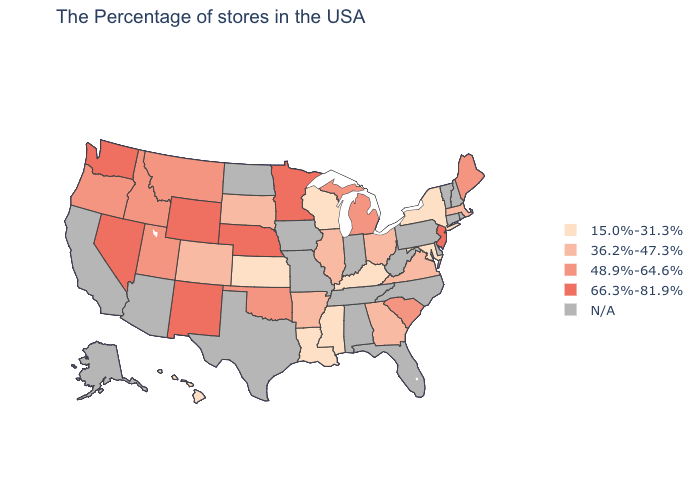What is the lowest value in states that border Kansas?
Quick response, please. 36.2%-47.3%. Does Kansas have the lowest value in the MidWest?
Quick response, please. Yes. What is the highest value in the USA?
Short answer required. 66.3%-81.9%. Name the states that have a value in the range 36.2%-47.3%?
Give a very brief answer. Massachusetts, Virginia, Ohio, Georgia, Illinois, Arkansas, South Dakota, Colorado. Among the states that border North Dakota , which have the highest value?
Write a very short answer. Minnesota. Does the map have missing data?
Give a very brief answer. Yes. What is the value of Colorado?
Short answer required. 36.2%-47.3%. Does the map have missing data?
Write a very short answer. Yes. Does Georgia have the lowest value in the USA?
Short answer required. No. Does Michigan have the lowest value in the USA?
Keep it brief. No. What is the lowest value in the West?
Write a very short answer. 15.0%-31.3%. Which states have the highest value in the USA?
Write a very short answer. New Jersey, Minnesota, Nebraska, Wyoming, New Mexico, Nevada, Washington. Is the legend a continuous bar?
Be succinct. No. Does Wisconsin have the lowest value in the MidWest?
Write a very short answer. Yes. 